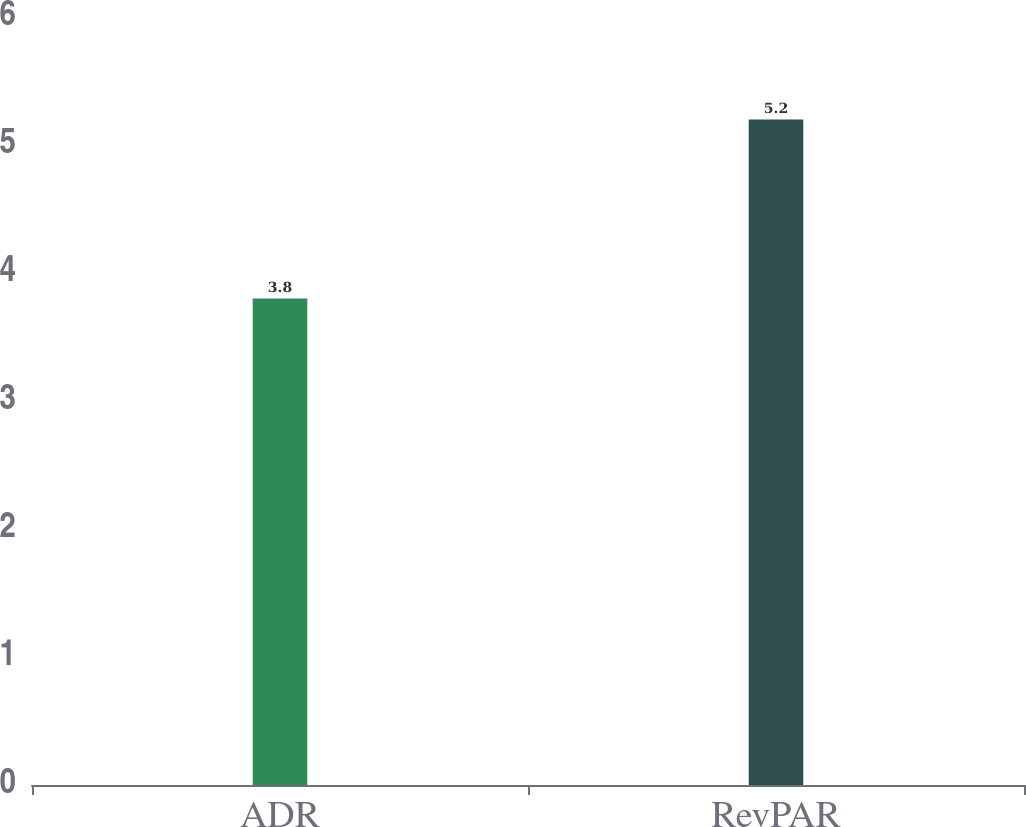Convert chart. <chart><loc_0><loc_0><loc_500><loc_500><bar_chart><fcel>ADR<fcel>RevPAR<nl><fcel>3.8<fcel>5.2<nl></chart> 